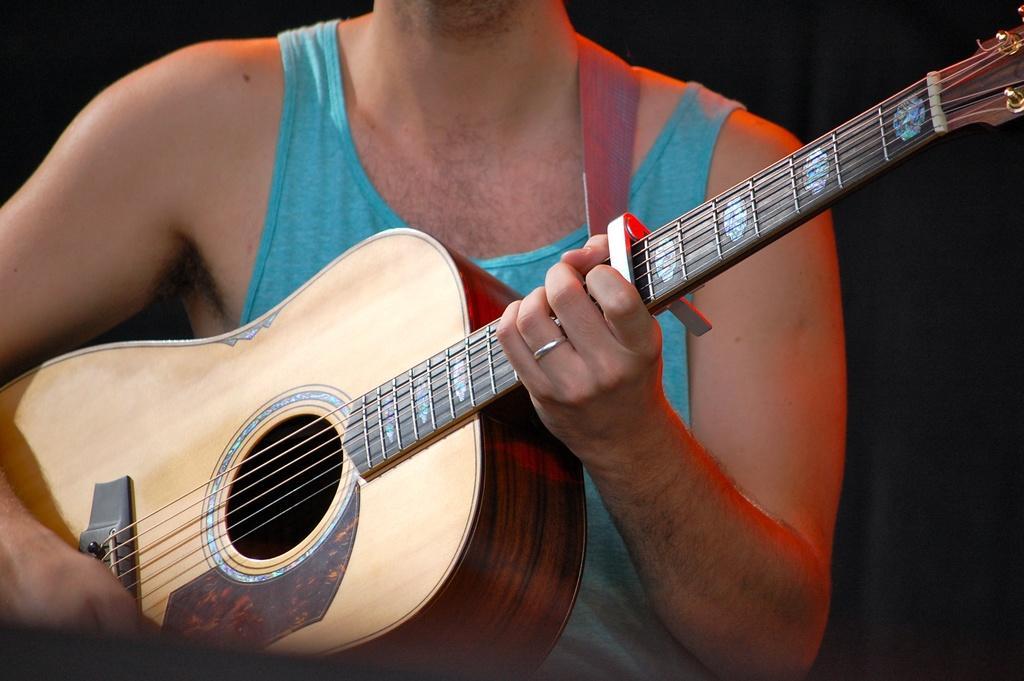In one or two sentences, can you explain what this image depicts? In this image we can see a person who is wearing a tank top and holding a guitar in his hands. 